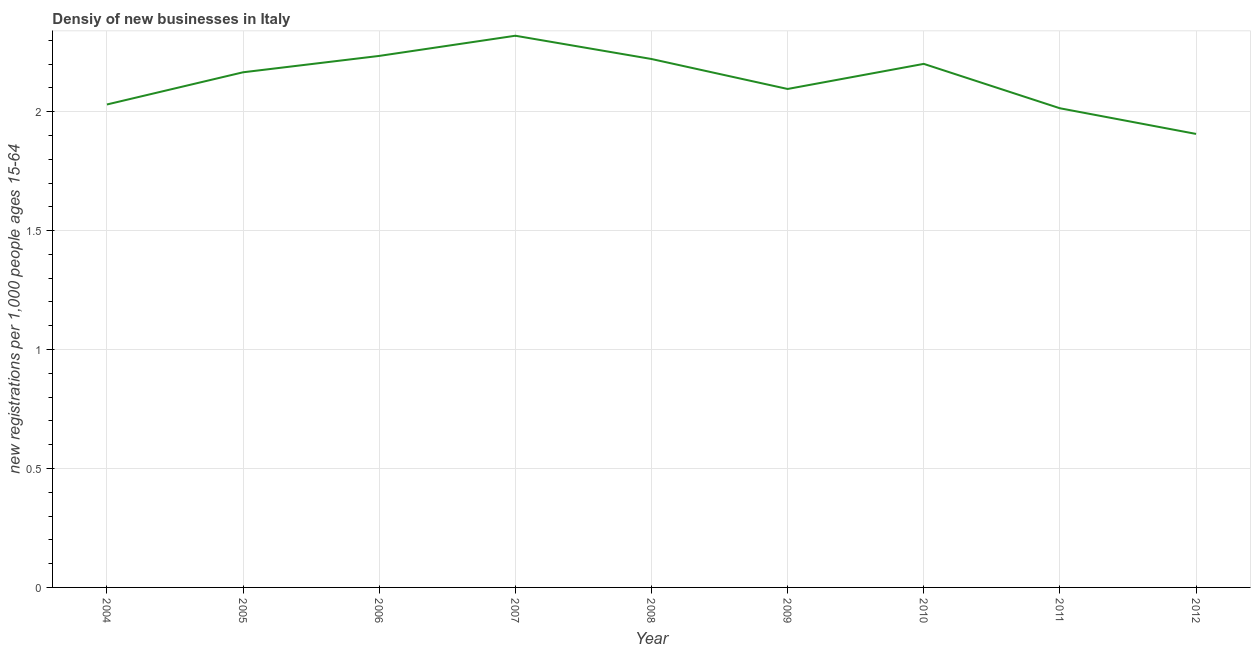What is the density of new business in 2005?
Your response must be concise. 2.17. Across all years, what is the maximum density of new business?
Your answer should be compact. 2.32. Across all years, what is the minimum density of new business?
Provide a succinct answer. 1.91. In which year was the density of new business minimum?
Offer a very short reply. 2012. What is the sum of the density of new business?
Ensure brevity in your answer.  19.19. What is the difference between the density of new business in 2007 and 2008?
Offer a terse response. 0.1. What is the average density of new business per year?
Your response must be concise. 2.13. What is the median density of new business?
Offer a very short reply. 2.17. In how many years, is the density of new business greater than 2.1 ?
Ensure brevity in your answer.  5. Do a majority of the years between 2006 and 2004 (inclusive) have density of new business greater than 1.7 ?
Your response must be concise. No. What is the ratio of the density of new business in 2007 to that in 2011?
Offer a very short reply. 1.15. What is the difference between the highest and the second highest density of new business?
Offer a very short reply. 0.08. Is the sum of the density of new business in 2010 and 2011 greater than the maximum density of new business across all years?
Give a very brief answer. Yes. What is the difference between the highest and the lowest density of new business?
Keep it short and to the point. 0.41. In how many years, is the density of new business greater than the average density of new business taken over all years?
Give a very brief answer. 5. Does the density of new business monotonically increase over the years?
Your response must be concise. No. How many lines are there?
Provide a succinct answer. 1. How many years are there in the graph?
Provide a short and direct response. 9. Are the values on the major ticks of Y-axis written in scientific E-notation?
Your response must be concise. No. Does the graph contain any zero values?
Give a very brief answer. No. What is the title of the graph?
Your answer should be very brief. Densiy of new businesses in Italy. What is the label or title of the Y-axis?
Ensure brevity in your answer.  New registrations per 1,0 people ages 15-64. What is the new registrations per 1,000 people ages 15-64 in 2004?
Provide a short and direct response. 2.03. What is the new registrations per 1,000 people ages 15-64 in 2005?
Give a very brief answer. 2.17. What is the new registrations per 1,000 people ages 15-64 of 2006?
Make the answer very short. 2.23. What is the new registrations per 1,000 people ages 15-64 of 2007?
Provide a short and direct response. 2.32. What is the new registrations per 1,000 people ages 15-64 in 2008?
Offer a terse response. 2.22. What is the new registrations per 1,000 people ages 15-64 of 2009?
Ensure brevity in your answer.  2.1. What is the new registrations per 1,000 people ages 15-64 of 2010?
Provide a short and direct response. 2.2. What is the new registrations per 1,000 people ages 15-64 of 2011?
Your answer should be very brief. 2.01. What is the new registrations per 1,000 people ages 15-64 in 2012?
Provide a short and direct response. 1.91. What is the difference between the new registrations per 1,000 people ages 15-64 in 2004 and 2005?
Your answer should be very brief. -0.14. What is the difference between the new registrations per 1,000 people ages 15-64 in 2004 and 2006?
Your answer should be compact. -0.2. What is the difference between the new registrations per 1,000 people ages 15-64 in 2004 and 2007?
Your answer should be compact. -0.29. What is the difference between the new registrations per 1,000 people ages 15-64 in 2004 and 2008?
Give a very brief answer. -0.19. What is the difference between the new registrations per 1,000 people ages 15-64 in 2004 and 2009?
Ensure brevity in your answer.  -0.07. What is the difference between the new registrations per 1,000 people ages 15-64 in 2004 and 2010?
Your response must be concise. -0.17. What is the difference between the new registrations per 1,000 people ages 15-64 in 2004 and 2011?
Your answer should be compact. 0.02. What is the difference between the new registrations per 1,000 people ages 15-64 in 2004 and 2012?
Ensure brevity in your answer.  0.12. What is the difference between the new registrations per 1,000 people ages 15-64 in 2005 and 2006?
Your answer should be very brief. -0.07. What is the difference between the new registrations per 1,000 people ages 15-64 in 2005 and 2007?
Make the answer very short. -0.15. What is the difference between the new registrations per 1,000 people ages 15-64 in 2005 and 2008?
Give a very brief answer. -0.06. What is the difference between the new registrations per 1,000 people ages 15-64 in 2005 and 2009?
Provide a short and direct response. 0.07. What is the difference between the new registrations per 1,000 people ages 15-64 in 2005 and 2010?
Make the answer very short. -0.04. What is the difference between the new registrations per 1,000 people ages 15-64 in 2005 and 2011?
Your response must be concise. 0.15. What is the difference between the new registrations per 1,000 people ages 15-64 in 2005 and 2012?
Ensure brevity in your answer.  0.26. What is the difference between the new registrations per 1,000 people ages 15-64 in 2006 and 2007?
Offer a very short reply. -0.08. What is the difference between the new registrations per 1,000 people ages 15-64 in 2006 and 2008?
Give a very brief answer. 0.01. What is the difference between the new registrations per 1,000 people ages 15-64 in 2006 and 2009?
Provide a short and direct response. 0.14. What is the difference between the new registrations per 1,000 people ages 15-64 in 2006 and 2010?
Offer a very short reply. 0.03. What is the difference between the new registrations per 1,000 people ages 15-64 in 2006 and 2011?
Offer a very short reply. 0.22. What is the difference between the new registrations per 1,000 people ages 15-64 in 2006 and 2012?
Your answer should be very brief. 0.33. What is the difference between the new registrations per 1,000 people ages 15-64 in 2007 and 2008?
Offer a terse response. 0.1. What is the difference between the new registrations per 1,000 people ages 15-64 in 2007 and 2009?
Offer a terse response. 0.22. What is the difference between the new registrations per 1,000 people ages 15-64 in 2007 and 2010?
Keep it short and to the point. 0.12. What is the difference between the new registrations per 1,000 people ages 15-64 in 2007 and 2011?
Offer a terse response. 0.3. What is the difference between the new registrations per 1,000 people ages 15-64 in 2007 and 2012?
Offer a terse response. 0.41. What is the difference between the new registrations per 1,000 people ages 15-64 in 2008 and 2009?
Your answer should be very brief. 0.13. What is the difference between the new registrations per 1,000 people ages 15-64 in 2008 and 2010?
Your answer should be very brief. 0.02. What is the difference between the new registrations per 1,000 people ages 15-64 in 2008 and 2011?
Make the answer very short. 0.21. What is the difference between the new registrations per 1,000 people ages 15-64 in 2008 and 2012?
Your answer should be very brief. 0.31. What is the difference between the new registrations per 1,000 people ages 15-64 in 2009 and 2010?
Offer a very short reply. -0.11. What is the difference between the new registrations per 1,000 people ages 15-64 in 2009 and 2011?
Keep it short and to the point. 0.08. What is the difference between the new registrations per 1,000 people ages 15-64 in 2009 and 2012?
Your answer should be compact. 0.19. What is the difference between the new registrations per 1,000 people ages 15-64 in 2010 and 2011?
Your answer should be very brief. 0.19. What is the difference between the new registrations per 1,000 people ages 15-64 in 2010 and 2012?
Offer a terse response. 0.29. What is the difference between the new registrations per 1,000 people ages 15-64 in 2011 and 2012?
Your answer should be compact. 0.11. What is the ratio of the new registrations per 1,000 people ages 15-64 in 2004 to that in 2005?
Ensure brevity in your answer.  0.94. What is the ratio of the new registrations per 1,000 people ages 15-64 in 2004 to that in 2006?
Give a very brief answer. 0.91. What is the ratio of the new registrations per 1,000 people ages 15-64 in 2004 to that in 2008?
Give a very brief answer. 0.91. What is the ratio of the new registrations per 1,000 people ages 15-64 in 2004 to that in 2010?
Offer a very short reply. 0.92. What is the ratio of the new registrations per 1,000 people ages 15-64 in 2004 to that in 2011?
Your answer should be compact. 1.01. What is the ratio of the new registrations per 1,000 people ages 15-64 in 2004 to that in 2012?
Make the answer very short. 1.06. What is the ratio of the new registrations per 1,000 people ages 15-64 in 2005 to that in 2006?
Provide a short and direct response. 0.97. What is the ratio of the new registrations per 1,000 people ages 15-64 in 2005 to that in 2007?
Your answer should be very brief. 0.93. What is the ratio of the new registrations per 1,000 people ages 15-64 in 2005 to that in 2009?
Ensure brevity in your answer.  1.03. What is the ratio of the new registrations per 1,000 people ages 15-64 in 2005 to that in 2010?
Give a very brief answer. 0.98. What is the ratio of the new registrations per 1,000 people ages 15-64 in 2005 to that in 2011?
Your response must be concise. 1.07. What is the ratio of the new registrations per 1,000 people ages 15-64 in 2005 to that in 2012?
Provide a succinct answer. 1.14. What is the ratio of the new registrations per 1,000 people ages 15-64 in 2006 to that in 2009?
Provide a short and direct response. 1.07. What is the ratio of the new registrations per 1,000 people ages 15-64 in 2006 to that in 2011?
Offer a terse response. 1.11. What is the ratio of the new registrations per 1,000 people ages 15-64 in 2006 to that in 2012?
Give a very brief answer. 1.17. What is the ratio of the new registrations per 1,000 people ages 15-64 in 2007 to that in 2008?
Give a very brief answer. 1.04. What is the ratio of the new registrations per 1,000 people ages 15-64 in 2007 to that in 2009?
Provide a succinct answer. 1.11. What is the ratio of the new registrations per 1,000 people ages 15-64 in 2007 to that in 2010?
Provide a short and direct response. 1.05. What is the ratio of the new registrations per 1,000 people ages 15-64 in 2007 to that in 2011?
Offer a very short reply. 1.15. What is the ratio of the new registrations per 1,000 people ages 15-64 in 2007 to that in 2012?
Give a very brief answer. 1.22. What is the ratio of the new registrations per 1,000 people ages 15-64 in 2008 to that in 2009?
Your answer should be compact. 1.06. What is the ratio of the new registrations per 1,000 people ages 15-64 in 2008 to that in 2010?
Provide a succinct answer. 1.01. What is the ratio of the new registrations per 1,000 people ages 15-64 in 2008 to that in 2011?
Keep it short and to the point. 1.1. What is the ratio of the new registrations per 1,000 people ages 15-64 in 2008 to that in 2012?
Offer a very short reply. 1.17. What is the ratio of the new registrations per 1,000 people ages 15-64 in 2009 to that in 2010?
Provide a succinct answer. 0.95. What is the ratio of the new registrations per 1,000 people ages 15-64 in 2009 to that in 2011?
Ensure brevity in your answer.  1.04. What is the ratio of the new registrations per 1,000 people ages 15-64 in 2009 to that in 2012?
Make the answer very short. 1.1. What is the ratio of the new registrations per 1,000 people ages 15-64 in 2010 to that in 2011?
Provide a short and direct response. 1.09. What is the ratio of the new registrations per 1,000 people ages 15-64 in 2010 to that in 2012?
Offer a terse response. 1.15. What is the ratio of the new registrations per 1,000 people ages 15-64 in 2011 to that in 2012?
Provide a short and direct response. 1.06. 